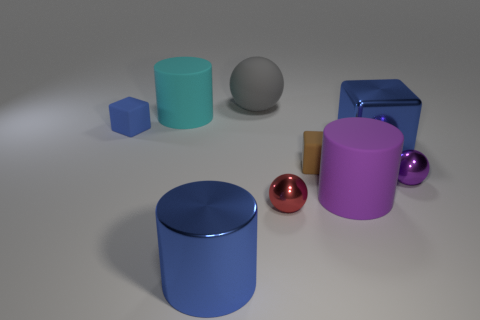Subtract 2 cylinders. How many cylinders are left? 1 Subtract all brown cubes. How many cubes are left? 2 Subtract all green metal things. Subtract all large cyan things. How many objects are left? 8 Add 1 large blocks. How many large blocks are left? 2 Add 3 purple matte cylinders. How many purple matte cylinders exist? 4 Subtract all blue cylinders. How many cylinders are left? 2 Subtract 0 gray cubes. How many objects are left? 9 Subtract all cylinders. How many objects are left? 6 Subtract all green spheres. Subtract all yellow cubes. How many spheres are left? 3 Subtract all gray blocks. How many cyan cylinders are left? 1 